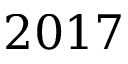<formula> <loc_0><loc_0><loc_500><loc_500>2 0 1 7</formula> 